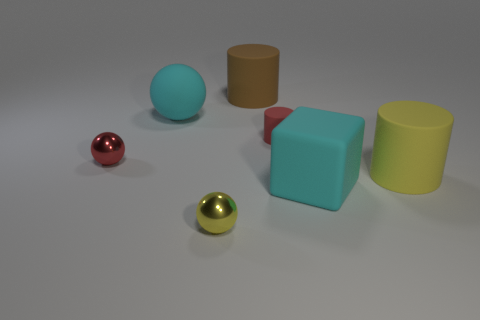Is there a pattern to the arrangement of the objects? There does not appear to be an intentional pattern to the arrangement of the objects. They are placed randomly with varying distances between them. 